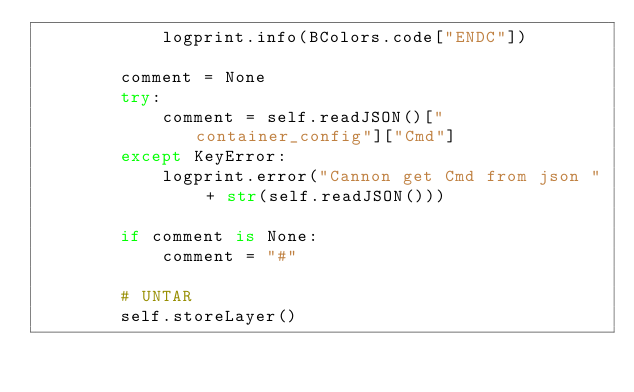Convert code to text. <code><loc_0><loc_0><loc_500><loc_500><_Python_>            logprint.info(BColors.code["ENDC"])

        comment = None
        try:
            comment = self.readJSON()["container_config"]["Cmd"]
        except KeyError:
            logprint.error("Cannon get Cmd from json " + str(self.readJSON()))

        if comment is None:
            comment = "#"

        # UNTAR
        self.storeLayer()
</code> 